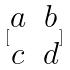Convert formula to latex. <formula><loc_0><loc_0><loc_500><loc_500>[ \begin{matrix} a & b \\ c & d \\ \end{matrix} ]</formula> 